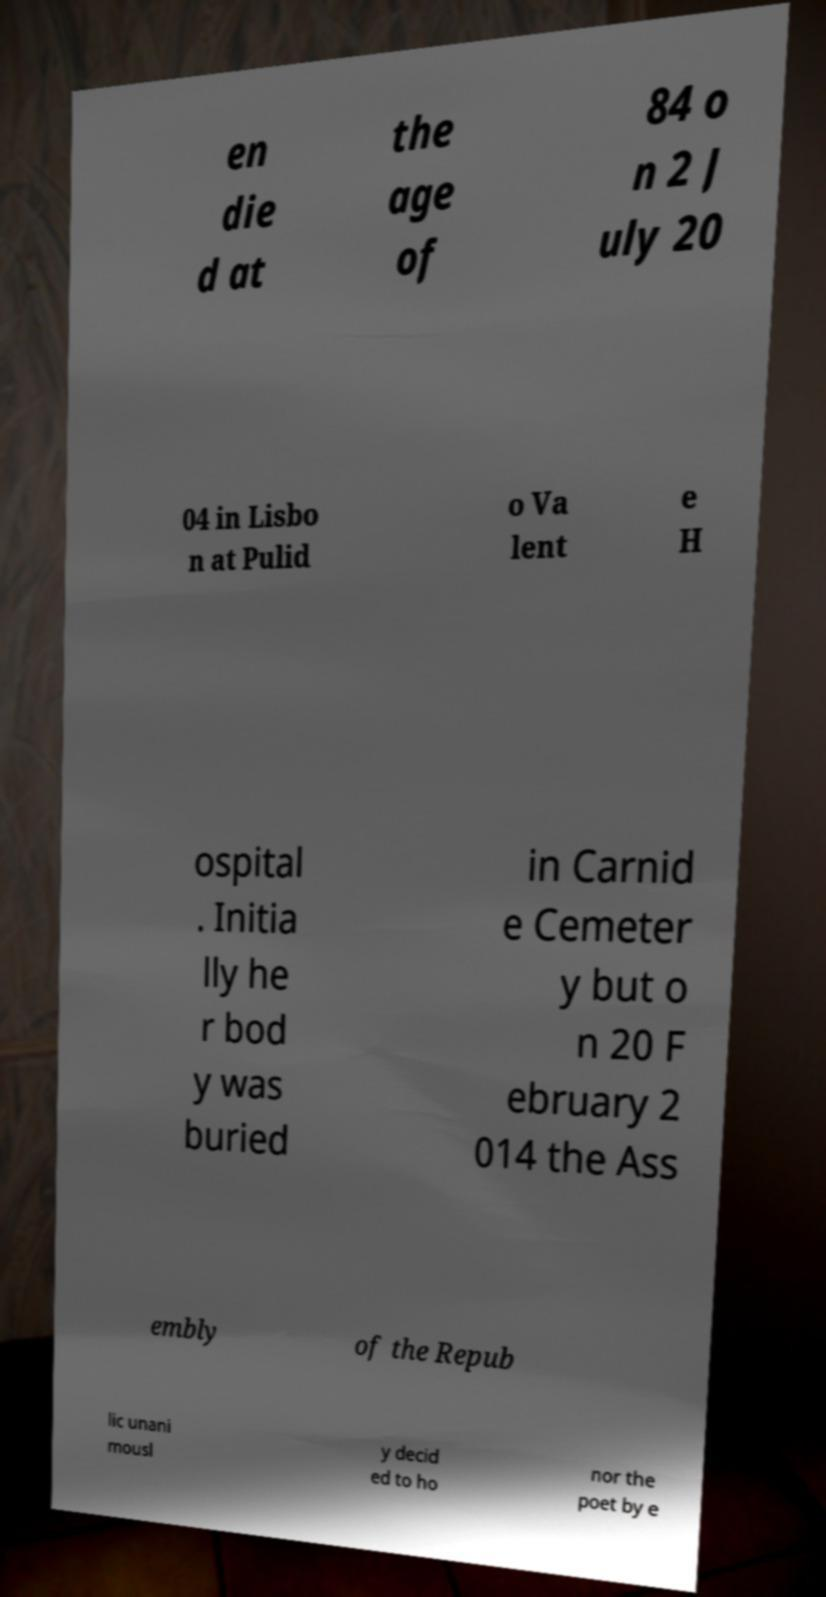Can you accurately transcribe the text from the provided image for me? en die d at the age of 84 o n 2 J uly 20 04 in Lisbo n at Pulid o Va lent e H ospital . Initia lly he r bod y was buried in Carnid e Cemeter y but o n 20 F ebruary 2 014 the Ass embly of the Repub lic unani mousl y decid ed to ho nor the poet by e 